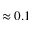Convert formula to latex. <formula><loc_0><loc_0><loc_500><loc_500>\approx 0 . 1</formula> 